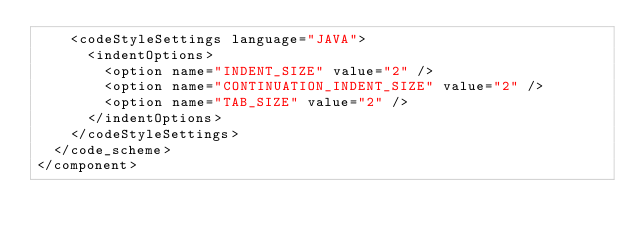Convert code to text. <code><loc_0><loc_0><loc_500><loc_500><_XML_>    <codeStyleSettings language="JAVA">
      <indentOptions>
        <option name="INDENT_SIZE" value="2" />
        <option name="CONTINUATION_INDENT_SIZE" value="2" />
        <option name="TAB_SIZE" value="2" />
      </indentOptions>
    </codeStyleSettings>
  </code_scheme>
</component></code> 